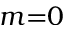Convert formula to latex. <formula><loc_0><loc_0><loc_500><loc_500>m { = } 0</formula> 